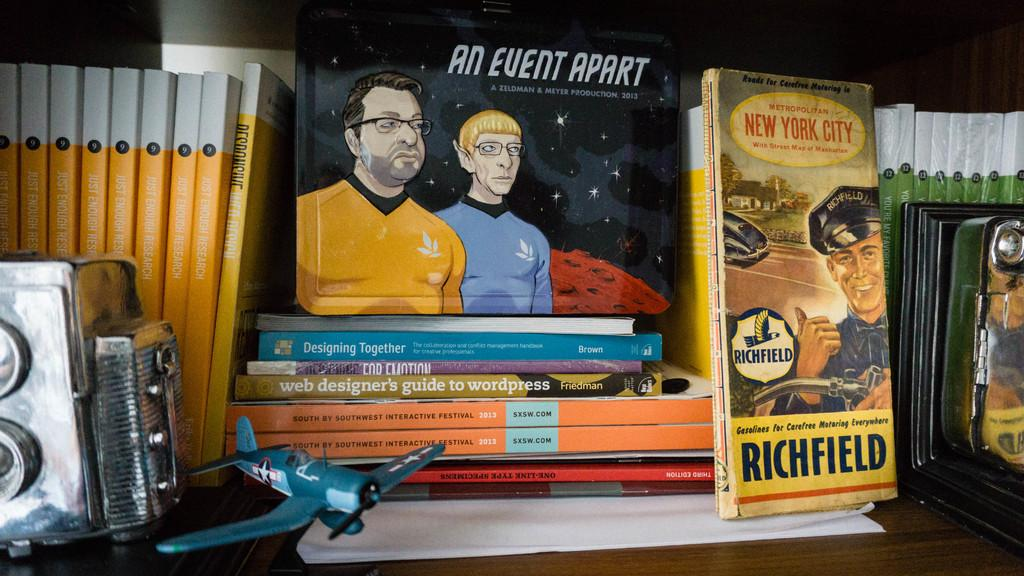Provide a one-sentence caption for the provided image. Several books are stacked including a book called An event apart and one called Richfield. 